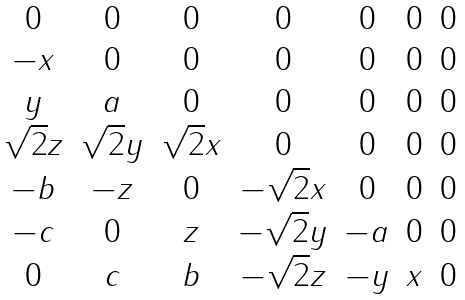<formula> <loc_0><loc_0><loc_500><loc_500>\begin{matrix} 0 & 0 & 0 & 0 & 0 & 0 & 0 \\ - x & 0 & 0 & 0 & 0 & 0 & 0 \\ y & a & 0 & 0 & 0 & 0 & 0 \\ \sqrt { 2 } z & \sqrt { 2 } y & \sqrt { 2 } x & 0 & 0 & 0 & 0 \\ - b & - z & 0 & - \sqrt { 2 } x & 0 & 0 & 0 \\ - c & 0 & z & - \sqrt { 2 } y & - a & 0 & 0 \\ 0 & c & b & - \sqrt { 2 } z & - y & x & 0 \end{matrix}</formula> 